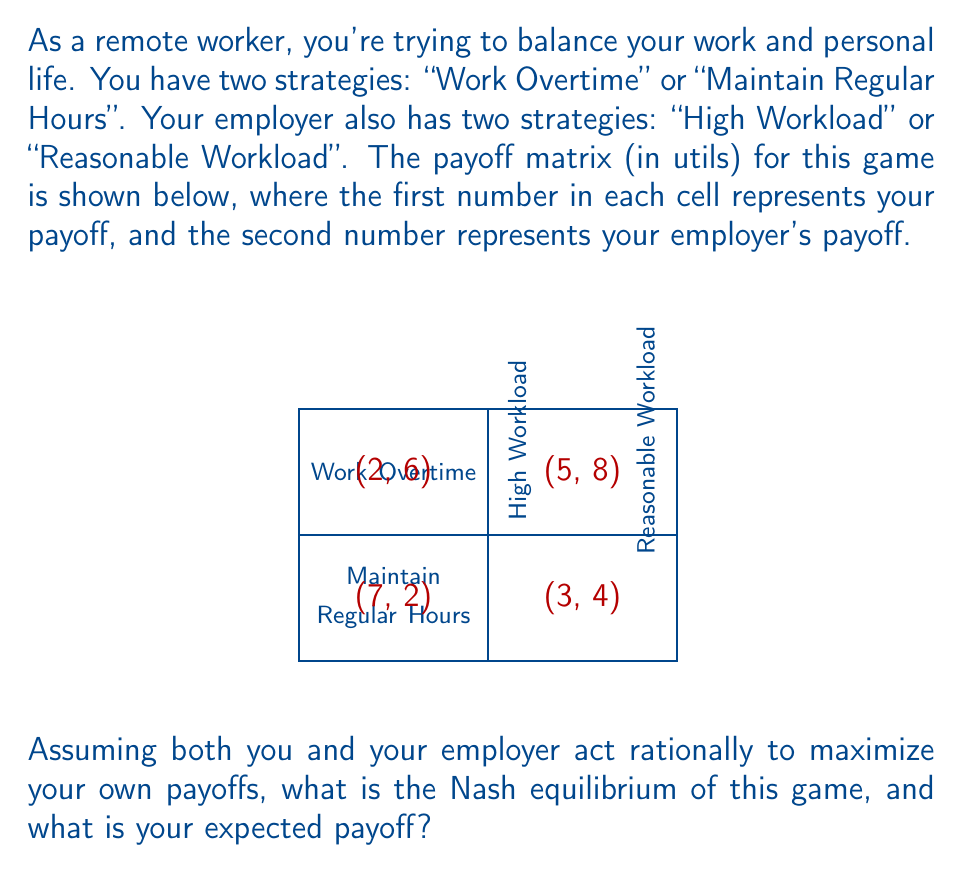Can you answer this question? To find the Nash equilibrium, we need to analyze the best responses for each player:

1. Your perspective:
   - If employer chooses "High Workload":
     Work Overtime: 5
     Maintain Regular Hours: 2
     Best response: Work Overtime
   - If employer chooses "Reasonable Workload":
     Work Overtime: 3
     Maintain Regular Hours: 7
     Best response: Maintain Regular Hours

2. Employer's perspective:
   - If you choose "Work Overtime":
     High Workload: 8
     Reasonable Workload: 4
     Best response: High Workload
   - If you choose "Maintain Regular Hours":
     High Workload: 6
     Reasonable Workload: 2
     Best response: High Workload

The Nash equilibrium occurs where both players are playing their best responses simultaneously. In this case, it's when you choose "Work Overtime" and your employer chooses "High Workload".

To verify:
- If you switch to "Maintain Regular Hours", your payoff decreases from 5 to 2.
- If your employer switches to "Reasonable Workload", their payoff decreases from 8 to 4.

Therefore, neither player has an incentive to unilaterally change their strategy.

The Nash equilibrium is (Work Overtime, High Workload), and your expected payoff is 5 utils.
Answer: Nash equilibrium: (Work Overtime, High Workload); Your payoff: 5 utils 